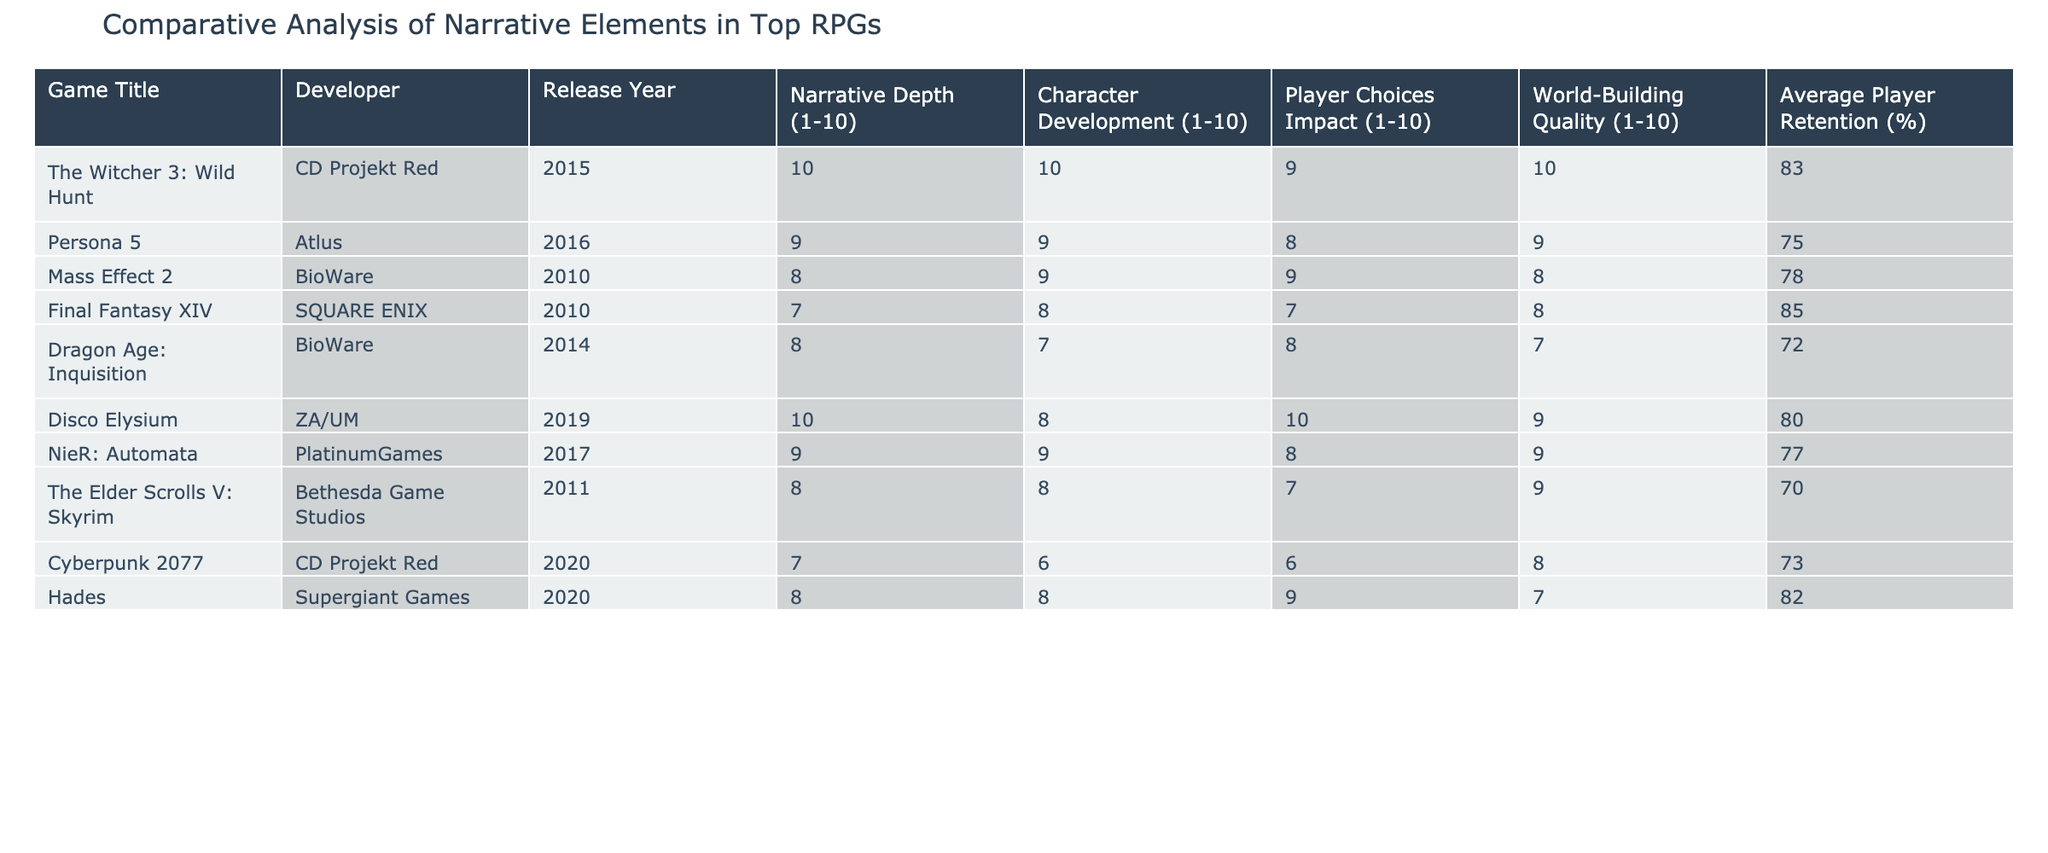What is the highest average player retention percentage in the table? Looking at the average player retention column, the game with the highest value is The Witcher 3: Wild Hunt, which has a retention rate of 83%.
Answer: 83% Which game has the lowest narrative depth score? The game with the lowest narrative depth score in the table is Cyberpunk 2077 with a score of 7.
Answer: 7 Is it true that Mass Effect 2 has a higher player choice impact score than Dragon Age: Inquisition? Yes, Mass Effect 2 has a player choice impact score of 9 while Dragon Age: Inquisition has a score of 8.
Answer: Yes What is the average narrative depth score of all the games listed? Adding the narrative depth scores: 10 + 9 + 8 + 7 + 8 + 10 + 9 + 8 + 7 + 7 = 81. There are 10 games, so the average is 81/10 = 8.1.
Answer: 8.1 Which game has the highest character development score? The game with the highest character development score is The Witcher 3: Wild Hunt, which scored 10.
Answer: 10 What is the difference in average player retention percentage between The Elder Scrolls V: Skyrim and Hades? The average player retention for The Elder Scrolls V: Skyrim is 70% and for Hades, it is 82%. The difference is 82% - 70% = 12%.
Answer: 12% Do Persona 5 and NieR: Automata have the same character development score? No, Persona 5 has a character development score of 9 while NieR: Automata has a score of 9 as well, but they do not share identical player choice impact or world-building quality scores.
Answer: No Which two games have the most similar scores in world-building quality? The games Cyberpunk 2077 and Final Fantasy XIV both have a world-building quality score of 8, making them the most similar in this category.
Answer: Cyberpunk 2077 and Final Fantasy XIV What is the sum of the character development scores for the top three games in average player retention? The top three games based on average player retention are The Witcher 3: Wild Hunt (10), Final Fantasy XIV (8), and Hades (8). The sum is 10 + 8 + 8 = 26.
Answer: 26 